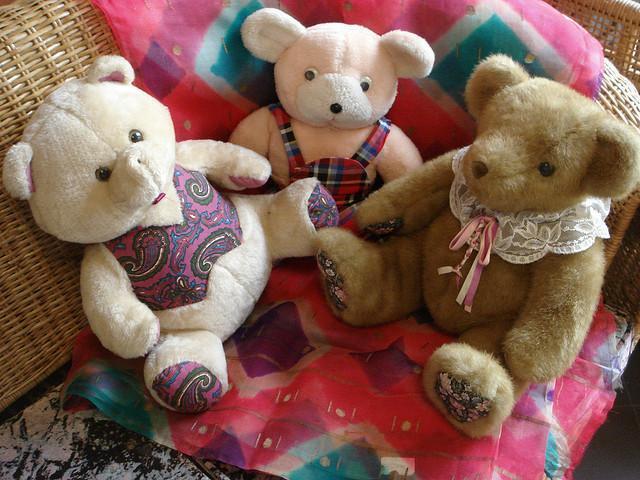How many of the stuffed animals are definitely female?
Give a very brief answer. 1. How many teddy bears are visible?
Give a very brief answer. 3. 